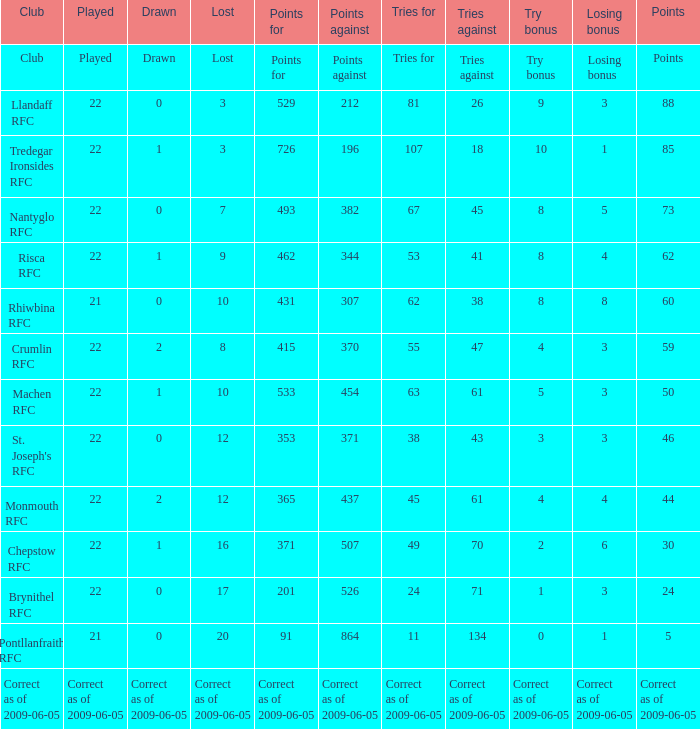If points against was 371, what is the drawn? 0.0. 